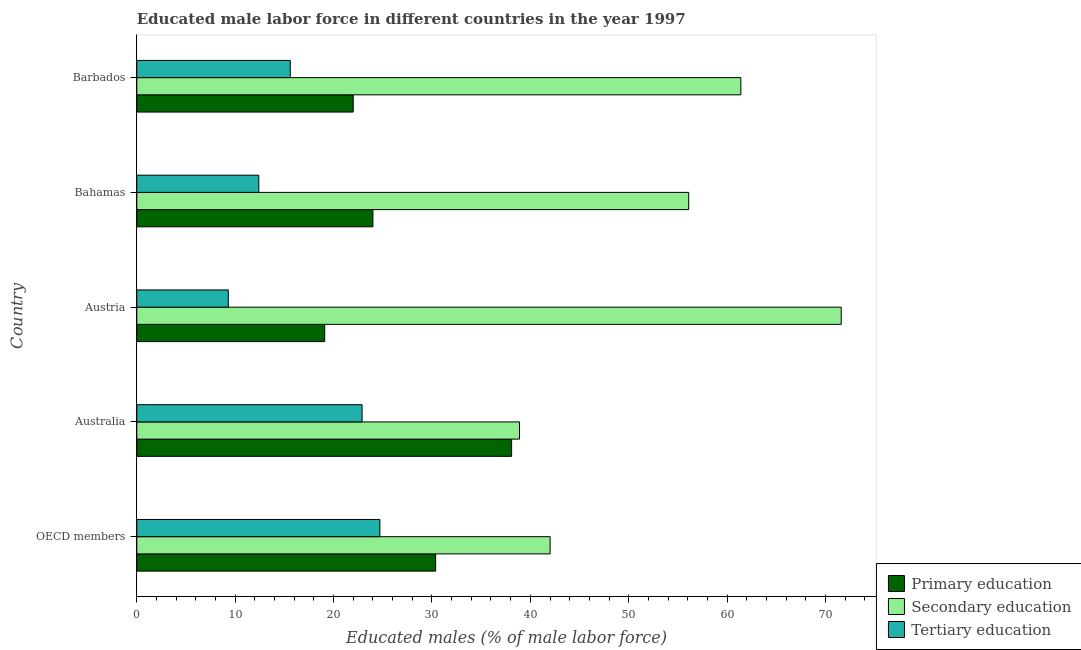How many different coloured bars are there?
Your response must be concise. 3. How many groups of bars are there?
Offer a terse response. 5. Are the number of bars on each tick of the Y-axis equal?
Make the answer very short. Yes. In how many cases, is the number of bars for a given country not equal to the number of legend labels?
Make the answer very short. 0. What is the percentage of male labor force who received primary education in Australia?
Give a very brief answer. 38.1. Across all countries, what is the maximum percentage of male labor force who received secondary education?
Make the answer very short. 71.6. Across all countries, what is the minimum percentage of male labor force who received secondary education?
Give a very brief answer. 38.9. In which country was the percentage of male labor force who received primary education minimum?
Provide a succinct answer. Austria. What is the total percentage of male labor force who received secondary education in the graph?
Your answer should be compact. 270.01. What is the difference between the percentage of male labor force who received tertiary education in Australia and the percentage of male labor force who received secondary education in Austria?
Give a very brief answer. -48.7. What is the average percentage of male labor force who received primary education per country?
Ensure brevity in your answer.  26.71. In how many countries, is the percentage of male labor force who received primary education greater than 34 %?
Keep it short and to the point. 1. What is the ratio of the percentage of male labor force who received primary education in Austria to that in Bahamas?
Provide a short and direct response. 0.8. What is the difference between the highest and the second highest percentage of male labor force who received primary education?
Provide a short and direct response. 7.72. In how many countries, is the percentage of male labor force who received primary education greater than the average percentage of male labor force who received primary education taken over all countries?
Make the answer very short. 2. What does the 2nd bar from the top in OECD members represents?
Provide a short and direct response. Secondary education. What does the 2nd bar from the bottom in Barbados represents?
Your response must be concise. Secondary education. Is it the case that in every country, the sum of the percentage of male labor force who received primary education and percentage of male labor force who received secondary education is greater than the percentage of male labor force who received tertiary education?
Offer a terse response. Yes. Are all the bars in the graph horizontal?
Keep it short and to the point. Yes. Are the values on the major ticks of X-axis written in scientific E-notation?
Provide a short and direct response. No. Does the graph contain any zero values?
Offer a terse response. No. Where does the legend appear in the graph?
Offer a very short reply. Bottom right. How many legend labels are there?
Keep it short and to the point. 3. What is the title of the graph?
Offer a very short reply. Educated male labor force in different countries in the year 1997. What is the label or title of the X-axis?
Make the answer very short. Educated males (% of male labor force). What is the Educated males (% of male labor force) of Primary education in OECD members?
Give a very brief answer. 30.38. What is the Educated males (% of male labor force) in Secondary education in OECD members?
Ensure brevity in your answer.  42.01. What is the Educated males (% of male labor force) of Tertiary education in OECD members?
Ensure brevity in your answer.  24.71. What is the Educated males (% of male labor force) in Primary education in Australia?
Ensure brevity in your answer.  38.1. What is the Educated males (% of male labor force) in Secondary education in Australia?
Offer a terse response. 38.9. What is the Educated males (% of male labor force) in Tertiary education in Australia?
Make the answer very short. 22.9. What is the Educated males (% of male labor force) in Primary education in Austria?
Ensure brevity in your answer.  19.1. What is the Educated males (% of male labor force) in Secondary education in Austria?
Keep it short and to the point. 71.6. What is the Educated males (% of male labor force) in Tertiary education in Austria?
Your answer should be compact. 9.3. What is the Educated males (% of male labor force) of Secondary education in Bahamas?
Your answer should be compact. 56.1. What is the Educated males (% of male labor force) in Tertiary education in Bahamas?
Your response must be concise. 12.4. What is the Educated males (% of male labor force) in Primary education in Barbados?
Offer a terse response. 22. What is the Educated males (% of male labor force) of Secondary education in Barbados?
Your answer should be very brief. 61.4. What is the Educated males (% of male labor force) of Tertiary education in Barbados?
Keep it short and to the point. 15.6. Across all countries, what is the maximum Educated males (% of male labor force) of Primary education?
Offer a terse response. 38.1. Across all countries, what is the maximum Educated males (% of male labor force) in Secondary education?
Provide a short and direct response. 71.6. Across all countries, what is the maximum Educated males (% of male labor force) of Tertiary education?
Offer a terse response. 24.71. Across all countries, what is the minimum Educated males (% of male labor force) in Primary education?
Your response must be concise. 19.1. Across all countries, what is the minimum Educated males (% of male labor force) in Secondary education?
Keep it short and to the point. 38.9. Across all countries, what is the minimum Educated males (% of male labor force) of Tertiary education?
Provide a short and direct response. 9.3. What is the total Educated males (% of male labor force) of Primary education in the graph?
Provide a short and direct response. 133.58. What is the total Educated males (% of male labor force) in Secondary education in the graph?
Your response must be concise. 270.01. What is the total Educated males (% of male labor force) of Tertiary education in the graph?
Offer a very short reply. 84.91. What is the difference between the Educated males (% of male labor force) in Primary education in OECD members and that in Australia?
Your answer should be compact. -7.72. What is the difference between the Educated males (% of male labor force) of Secondary education in OECD members and that in Australia?
Keep it short and to the point. 3.11. What is the difference between the Educated males (% of male labor force) of Tertiary education in OECD members and that in Australia?
Ensure brevity in your answer.  1.81. What is the difference between the Educated males (% of male labor force) in Primary education in OECD members and that in Austria?
Provide a succinct answer. 11.28. What is the difference between the Educated males (% of male labor force) in Secondary education in OECD members and that in Austria?
Offer a very short reply. -29.59. What is the difference between the Educated males (% of male labor force) of Tertiary education in OECD members and that in Austria?
Ensure brevity in your answer.  15.41. What is the difference between the Educated males (% of male labor force) in Primary education in OECD members and that in Bahamas?
Your answer should be very brief. 6.38. What is the difference between the Educated males (% of male labor force) of Secondary education in OECD members and that in Bahamas?
Provide a short and direct response. -14.09. What is the difference between the Educated males (% of male labor force) of Tertiary education in OECD members and that in Bahamas?
Keep it short and to the point. 12.31. What is the difference between the Educated males (% of male labor force) of Primary education in OECD members and that in Barbados?
Ensure brevity in your answer.  8.38. What is the difference between the Educated males (% of male labor force) of Secondary education in OECD members and that in Barbados?
Ensure brevity in your answer.  -19.39. What is the difference between the Educated males (% of male labor force) in Tertiary education in OECD members and that in Barbados?
Provide a succinct answer. 9.11. What is the difference between the Educated males (% of male labor force) in Secondary education in Australia and that in Austria?
Keep it short and to the point. -32.7. What is the difference between the Educated males (% of male labor force) of Primary education in Australia and that in Bahamas?
Give a very brief answer. 14.1. What is the difference between the Educated males (% of male labor force) of Secondary education in Australia and that in Bahamas?
Your answer should be compact. -17.2. What is the difference between the Educated males (% of male labor force) of Tertiary education in Australia and that in Bahamas?
Provide a succinct answer. 10.5. What is the difference between the Educated males (% of male labor force) in Primary education in Australia and that in Barbados?
Offer a very short reply. 16.1. What is the difference between the Educated males (% of male labor force) in Secondary education in Australia and that in Barbados?
Your response must be concise. -22.5. What is the difference between the Educated males (% of male labor force) of Tertiary education in Australia and that in Barbados?
Provide a succinct answer. 7.3. What is the difference between the Educated males (% of male labor force) of Primary education in Austria and that in Bahamas?
Provide a short and direct response. -4.9. What is the difference between the Educated males (% of male labor force) in Secondary education in Austria and that in Bahamas?
Offer a very short reply. 15.5. What is the difference between the Educated males (% of male labor force) of Tertiary education in Austria and that in Bahamas?
Ensure brevity in your answer.  -3.1. What is the difference between the Educated males (% of male labor force) of Secondary education in Austria and that in Barbados?
Your response must be concise. 10.2. What is the difference between the Educated males (% of male labor force) in Tertiary education in Austria and that in Barbados?
Offer a very short reply. -6.3. What is the difference between the Educated males (% of male labor force) of Tertiary education in Bahamas and that in Barbados?
Your answer should be very brief. -3.2. What is the difference between the Educated males (% of male labor force) of Primary education in OECD members and the Educated males (% of male labor force) of Secondary education in Australia?
Give a very brief answer. -8.52. What is the difference between the Educated males (% of male labor force) of Primary education in OECD members and the Educated males (% of male labor force) of Tertiary education in Australia?
Ensure brevity in your answer.  7.48. What is the difference between the Educated males (% of male labor force) of Secondary education in OECD members and the Educated males (% of male labor force) of Tertiary education in Australia?
Provide a short and direct response. 19.11. What is the difference between the Educated males (% of male labor force) of Primary education in OECD members and the Educated males (% of male labor force) of Secondary education in Austria?
Ensure brevity in your answer.  -41.22. What is the difference between the Educated males (% of male labor force) in Primary education in OECD members and the Educated males (% of male labor force) in Tertiary education in Austria?
Make the answer very short. 21.08. What is the difference between the Educated males (% of male labor force) in Secondary education in OECD members and the Educated males (% of male labor force) in Tertiary education in Austria?
Give a very brief answer. 32.71. What is the difference between the Educated males (% of male labor force) in Primary education in OECD members and the Educated males (% of male labor force) in Secondary education in Bahamas?
Provide a short and direct response. -25.72. What is the difference between the Educated males (% of male labor force) of Primary education in OECD members and the Educated males (% of male labor force) of Tertiary education in Bahamas?
Give a very brief answer. 17.98. What is the difference between the Educated males (% of male labor force) in Secondary education in OECD members and the Educated males (% of male labor force) in Tertiary education in Bahamas?
Your response must be concise. 29.61. What is the difference between the Educated males (% of male labor force) in Primary education in OECD members and the Educated males (% of male labor force) in Secondary education in Barbados?
Offer a very short reply. -31.02. What is the difference between the Educated males (% of male labor force) of Primary education in OECD members and the Educated males (% of male labor force) of Tertiary education in Barbados?
Give a very brief answer. 14.78. What is the difference between the Educated males (% of male labor force) in Secondary education in OECD members and the Educated males (% of male labor force) in Tertiary education in Barbados?
Offer a terse response. 26.41. What is the difference between the Educated males (% of male labor force) of Primary education in Australia and the Educated males (% of male labor force) of Secondary education in Austria?
Provide a succinct answer. -33.5. What is the difference between the Educated males (% of male labor force) of Primary education in Australia and the Educated males (% of male labor force) of Tertiary education in Austria?
Your answer should be very brief. 28.8. What is the difference between the Educated males (% of male labor force) of Secondary education in Australia and the Educated males (% of male labor force) of Tertiary education in Austria?
Give a very brief answer. 29.6. What is the difference between the Educated males (% of male labor force) of Primary education in Australia and the Educated males (% of male labor force) of Secondary education in Bahamas?
Provide a succinct answer. -18. What is the difference between the Educated males (% of male labor force) of Primary education in Australia and the Educated males (% of male labor force) of Tertiary education in Bahamas?
Offer a very short reply. 25.7. What is the difference between the Educated males (% of male labor force) of Secondary education in Australia and the Educated males (% of male labor force) of Tertiary education in Bahamas?
Give a very brief answer. 26.5. What is the difference between the Educated males (% of male labor force) in Primary education in Australia and the Educated males (% of male labor force) in Secondary education in Barbados?
Provide a short and direct response. -23.3. What is the difference between the Educated males (% of male labor force) of Secondary education in Australia and the Educated males (% of male labor force) of Tertiary education in Barbados?
Make the answer very short. 23.3. What is the difference between the Educated males (% of male labor force) of Primary education in Austria and the Educated males (% of male labor force) of Secondary education in Bahamas?
Offer a very short reply. -37. What is the difference between the Educated males (% of male labor force) of Primary education in Austria and the Educated males (% of male labor force) of Tertiary education in Bahamas?
Make the answer very short. 6.7. What is the difference between the Educated males (% of male labor force) of Secondary education in Austria and the Educated males (% of male labor force) of Tertiary education in Bahamas?
Ensure brevity in your answer.  59.2. What is the difference between the Educated males (% of male labor force) in Primary education in Austria and the Educated males (% of male labor force) in Secondary education in Barbados?
Provide a short and direct response. -42.3. What is the difference between the Educated males (% of male labor force) of Primary education in Austria and the Educated males (% of male labor force) of Tertiary education in Barbados?
Your answer should be compact. 3.5. What is the difference between the Educated males (% of male labor force) in Secondary education in Austria and the Educated males (% of male labor force) in Tertiary education in Barbados?
Ensure brevity in your answer.  56. What is the difference between the Educated males (% of male labor force) in Primary education in Bahamas and the Educated males (% of male labor force) in Secondary education in Barbados?
Offer a terse response. -37.4. What is the difference between the Educated males (% of male labor force) in Primary education in Bahamas and the Educated males (% of male labor force) in Tertiary education in Barbados?
Give a very brief answer. 8.4. What is the difference between the Educated males (% of male labor force) of Secondary education in Bahamas and the Educated males (% of male labor force) of Tertiary education in Barbados?
Your response must be concise. 40.5. What is the average Educated males (% of male labor force) in Primary education per country?
Your answer should be compact. 26.72. What is the average Educated males (% of male labor force) of Secondary education per country?
Provide a short and direct response. 54. What is the average Educated males (% of male labor force) of Tertiary education per country?
Make the answer very short. 16.98. What is the difference between the Educated males (% of male labor force) of Primary education and Educated males (% of male labor force) of Secondary education in OECD members?
Offer a terse response. -11.64. What is the difference between the Educated males (% of male labor force) of Primary education and Educated males (% of male labor force) of Tertiary education in OECD members?
Give a very brief answer. 5.67. What is the difference between the Educated males (% of male labor force) of Secondary education and Educated males (% of male labor force) of Tertiary education in OECD members?
Your response must be concise. 17.3. What is the difference between the Educated males (% of male labor force) in Primary education and Educated males (% of male labor force) in Secondary education in Australia?
Offer a very short reply. -0.8. What is the difference between the Educated males (% of male labor force) in Primary education and Educated males (% of male labor force) in Tertiary education in Australia?
Provide a short and direct response. 15.2. What is the difference between the Educated males (% of male labor force) of Secondary education and Educated males (% of male labor force) of Tertiary education in Australia?
Your response must be concise. 16. What is the difference between the Educated males (% of male labor force) of Primary education and Educated males (% of male labor force) of Secondary education in Austria?
Provide a short and direct response. -52.5. What is the difference between the Educated males (% of male labor force) in Secondary education and Educated males (% of male labor force) in Tertiary education in Austria?
Ensure brevity in your answer.  62.3. What is the difference between the Educated males (% of male labor force) in Primary education and Educated males (% of male labor force) in Secondary education in Bahamas?
Make the answer very short. -32.1. What is the difference between the Educated males (% of male labor force) in Secondary education and Educated males (% of male labor force) in Tertiary education in Bahamas?
Provide a short and direct response. 43.7. What is the difference between the Educated males (% of male labor force) in Primary education and Educated males (% of male labor force) in Secondary education in Barbados?
Make the answer very short. -39.4. What is the difference between the Educated males (% of male labor force) of Primary education and Educated males (% of male labor force) of Tertiary education in Barbados?
Give a very brief answer. 6.4. What is the difference between the Educated males (% of male labor force) of Secondary education and Educated males (% of male labor force) of Tertiary education in Barbados?
Your answer should be very brief. 45.8. What is the ratio of the Educated males (% of male labor force) in Primary education in OECD members to that in Australia?
Make the answer very short. 0.8. What is the ratio of the Educated males (% of male labor force) in Tertiary education in OECD members to that in Australia?
Offer a terse response. 1.08. What is the ratio of the Educated males (% of male labor force) of Primary education in OECD members to that in Austria?
Your answer should be compact. 1.59. What is the ratio of the Educated males (% of male labor force) of Secondary education in OECD members to that in Austria?
Your answer should be very brief. 0.59. What is the ratio of the Educated males (% of male labor force) of Tertiary education in OECD members to that in Austria?
Your response must be concise. 2.66. What is the ratio of the Educated males (% of male labor force) of Primary education in OECD members to that in Bahamas?
Your answer should be very brief. 1.27. What is the ratio of the Educated males (% of male labor force) of Secondary education in OECD members to that in Bahamas?
Your answer should be very brief. 0.75. What is the ratio of the Educated males (% of male labor force) of Tertiary education in OECD members to that in Bahamas?
Give a very brief answer. 1.99. What is the ratio of the Educated males (% of male labor force) in Primary education in OECD members to that in Barbados?
Your answer should be very brief. 1.38. What is the ratio of the Educated males (% of male labor force) of Secondary education in OECD members to that in Barbados?
Provide a succinct answer. 0.68. What is the ratio of the Educated males (% of male labor force) of Tertiary education in OECD members to that in Barbados?
Your response must be concise. 1.58. What is the ratio of the Educated males (% of male labor force) in Primary education in Australia to that in Austria?
Offer a very short reply. 1.99. What is the ratio of the Educated males (% of male labor force) in Secondary education in Australia to that in Austria?
Provide a succinct answer. 0.54. What is the ratio of the Educated males (% of male labor force) in Tertiary education in Australia to that in Austria?
Give a very brief answer. 2.46. What is the ratio of the Educated males (% of male labor force) in Primary education in Australia to that in Bahamas?
Keep it short and to the point. 1.59. What is the ratio of the Educated males (% of male labor force) of Secondary education in Australia to that in Bahamas?
Provide a succinct answer. 0.69. What is the ratio of the Educated males (% of male labor force) of Tertiary education in Australia to that in Bahamas?
Your answer should be very brief. 1.85. What is the ratio of the Educated males (% of male labor force) of Primary education in Australia to that in Barbados?
Keep it short and to the point. 1.73. What is the ratio of the Educated males (% of male labor force) in Secondary education in Australia to that in Barbados?
Your answer should be compact. 0.63. What is the ratio of the Educated males (% of male labor force) in Tertiary education in Australia to that in Barbados?
Provide a short and direct response. 1.47. What is the ratio of the Educated males (% of male labor force) of Primary education in Austria to that in Bahamas?
Give a very brief answer. 0.8. What is the ratio of the Educated males (% of male labor force) in Secondary education in Austria to that in Bahamas?
Your answer should be compact. 1.28. What is the ratio of the Educated males (% of male labor force) of Primary education in Austria to that in Barbados?
Your answer should be very brief. 0.87. What is the ratio of the Educated males (% of male labor force) of Secondary education in Austria to that in Barbados?
Provide a short and direct response. 1.17. What is the ratio of the Educated males (% of male labor force) of Tertiary education in Austria to that in Barbados?
Make the answer very short. 0.6. What is the ratio of the Educated males (% of male labor force) in Secondary education in Bahamas to that in Barbados?
Give a very brief answer. 0.91. What is the ratio of the Educated males (% of male labor force) of Tertiary education in Bahamas to that in Barbados?
Offer a terse response. 0.79. What is the difference between the highest and the second highest Educated males (% of male labor force) of Primary education?
Your response must be concise. 7.72. What is the difference between the highest and the second highest Educated males (% of male labor force) in Secondary education?
Provide a succinct answer. 10.2. What is the difference between the highest and the second highest Educated males (% of male labor force) in Tertiary education?
Your answer should be very brief. 1.81. What is the difference between the highest and the lowest Educated males (% of male labor force) in Secondary education?
Offer a terse response. 32.7. What is the difference between the highest and the lowest Educated males (% of male labor force) in Tertiary education?
Give a very brief answer. 15.41. 